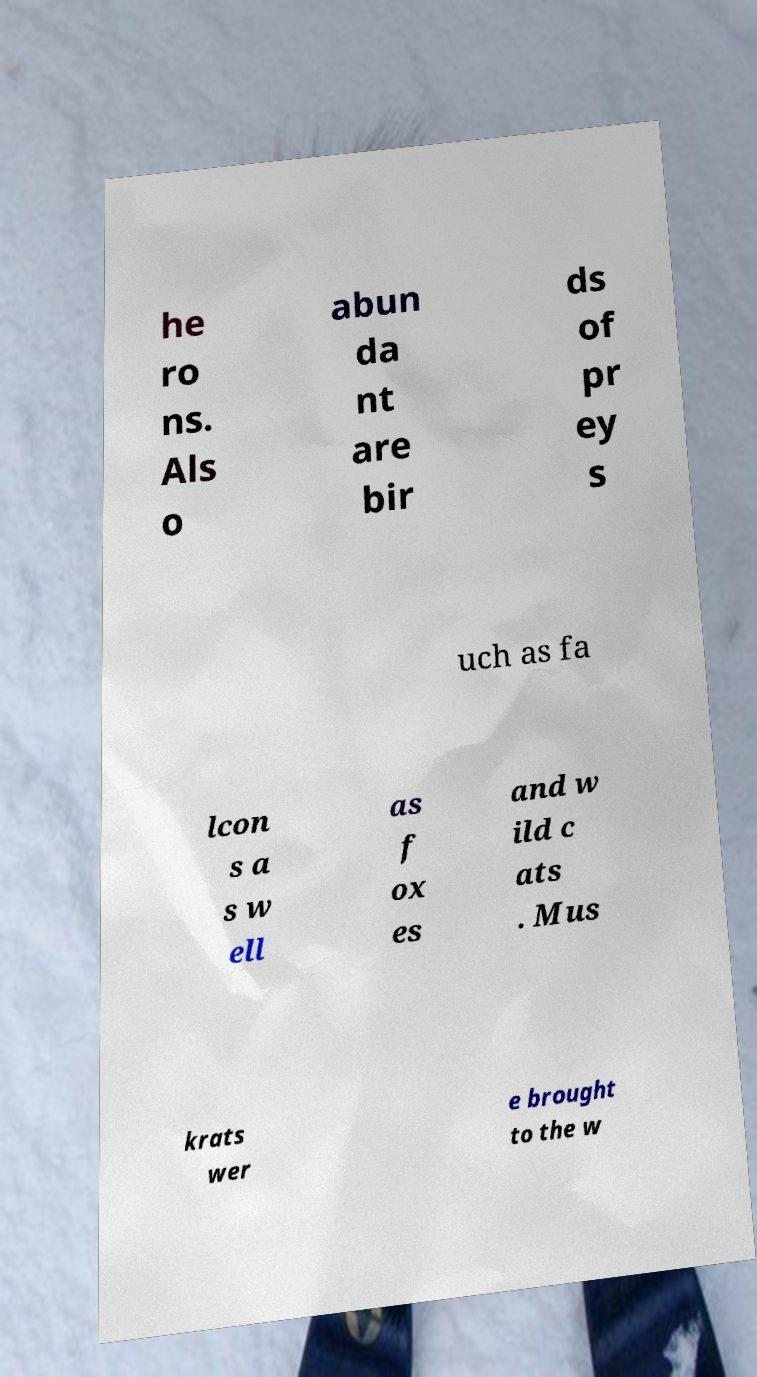I need the written content from this picture converted into text. Can you do that? he ro ns. Als o abun da nt are bir ds of pr ey s uch as fa lcon s a s w ell as f ox es and w ild c ats . Mus krats wer e brought to the w 